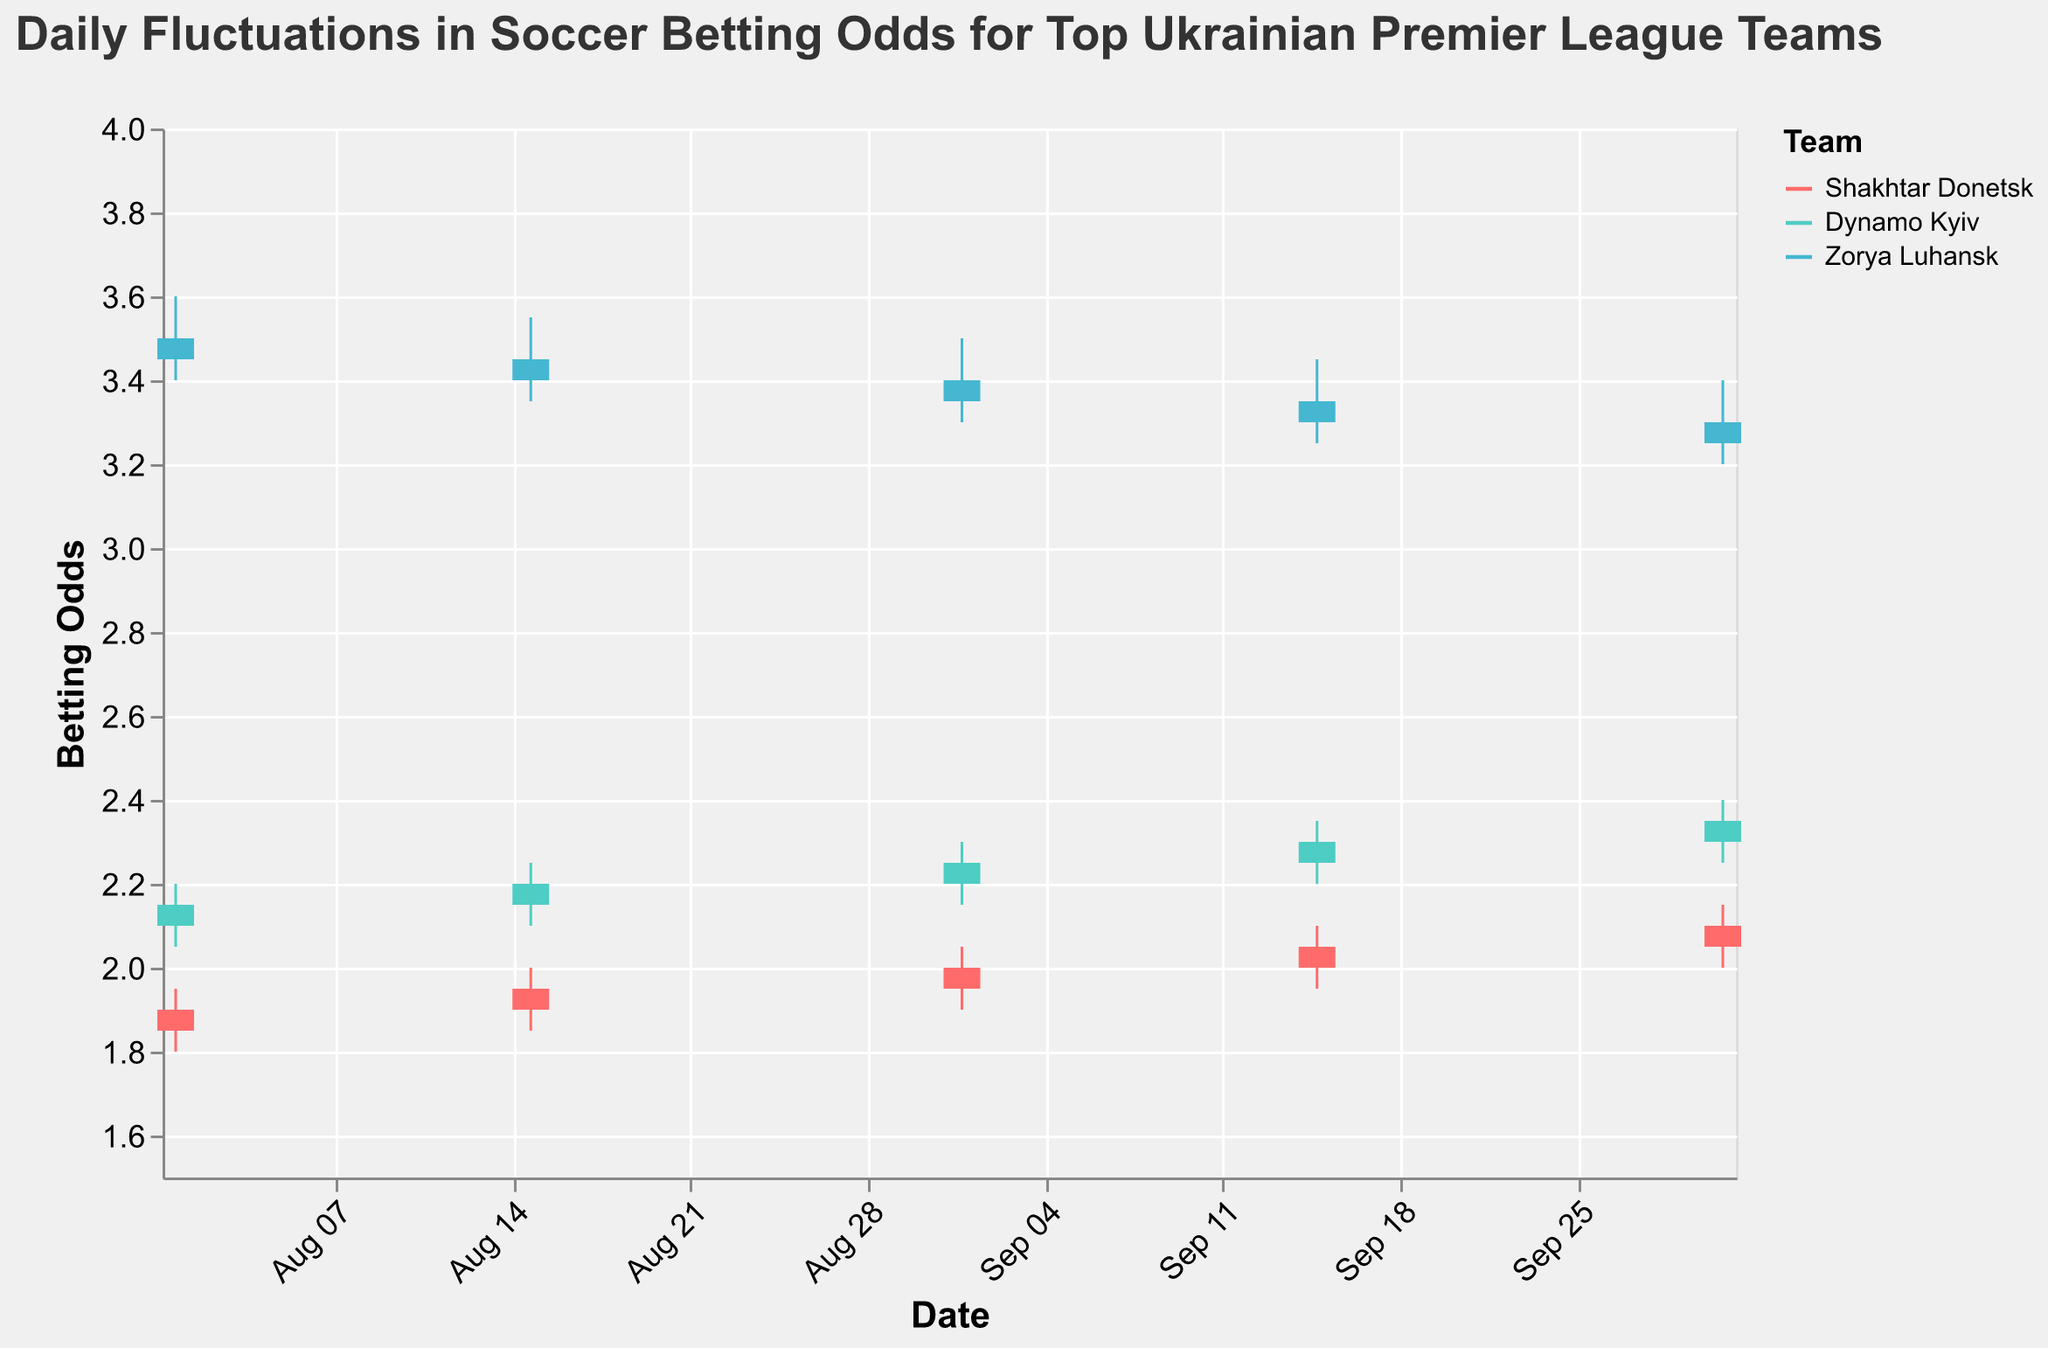What teams are represented in the chart? Look at the legend of the chart, which shows the teams and their associated colors. The teams are "Shakhtar Donetsk", "Dynamo Kyiv", and "Zorya Luhansk".
Answer: Shakhtar Donetsk, Dynamo Kyiv, Zorya Luhansk What is the title of the chart? The title is located at the top of the chart and reads: "Daily Fluctuations in Soccer Betting Odds for Top Ukrainian Premier League Teams".
Answer: Daily Fluctuations in Soccer Betting Odds for Top Ukrainian Premier League Teams On which date did Dynamo Kyiv have the highest betting odds? By inspecting the highest "High" values for Dynamo Kyiv over different dates, the highest value occurred on "2022-10-01" with an odds of 2.40.
Answer: 2022-10-01 Compare the closing betting odds of Shakhtar Donetsk and Dynamo Kyiv on 2022-09-01. Which team had higher closing odds? Check the "Close" values for both teams on "2022-09-01". Shakhtar Donetsk had 2.00, and Dynamo Kyiv had 2.25.
Answer: Dynamo Kyiv What was the lowest betting odds for Zorya Luhansk in the data provided? Inspect the "Low" column for all dates for Zorya Luhansk. The lowest value is 3.20 on "2022-10-01".
Answer: 3.20 Calculate the average closing odds for Shakhtar Donetsk over the season displayed. Add up all the closing odds for Shakhtar Donetsk: 1.90 + 1.95 + 2.00 + 2.05 + 2.10 = 10.00. Divide by the number of dates (5): 10.00 / 5 = 2.00.
Answer: 2.00 Did any team always have higher open odds than Shakhtar Donetsk on the same date? Compare the "Open" values of Dynamo Kyiv and Zorya Luhansk to Shakhtar Donetsk for each date. Both teams always had higher open odds than Shakhtar Donetsk.
Answer: Yes Which team showed a general upward trend in their closing odds over time? Examine the closing odds over time for each team. Shakhtar Donetsk's closing odds increased from 1.90 to 2.10.
Answer: Shakhtar Donetsk How many dates are shown for the betting odds data? Count the unique dates in the "Date" column. There are 5 unique dates: "2022-08-01", "2022-08-15", "2022-09-01", "2022-09-15", and "2022-10-01".
Answer: 5 